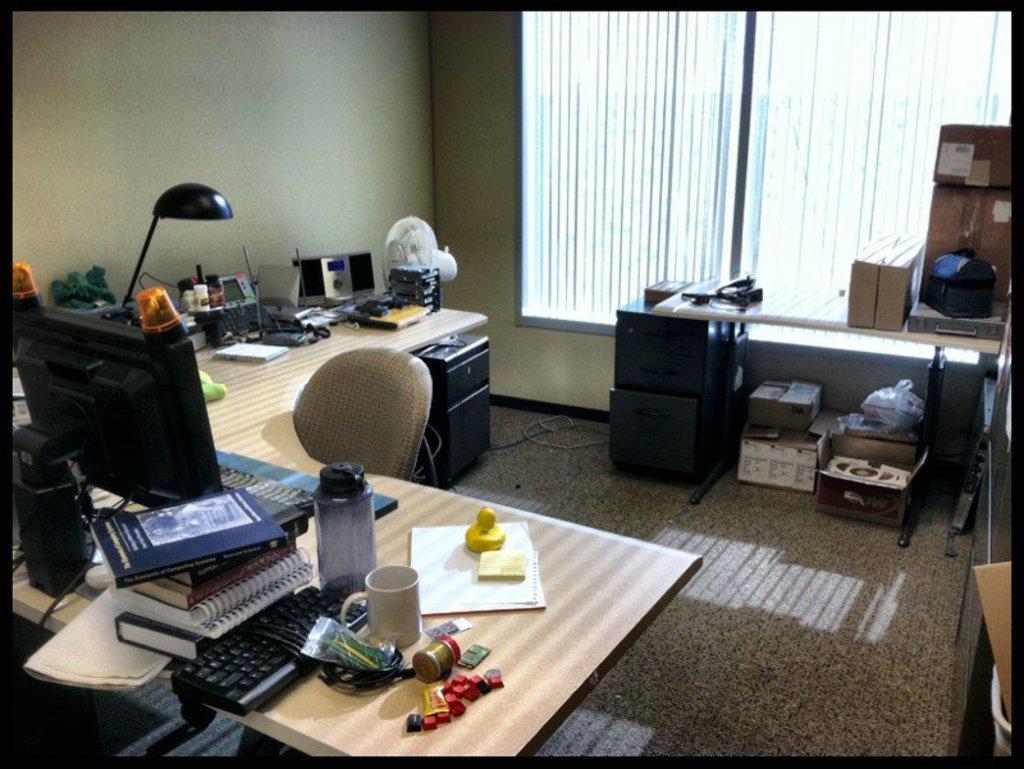Can you describe this image briefly? A work space with a desktop,chair and a table with some boxes on it. 